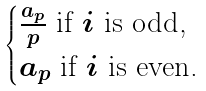<formula> <loc_0><loc_0><loc_500><loc_500>\begin{cases} \frac { a _ { p } } { p } \text { if $i$ is odd,} \\ a _ { p } \text { if $i$ is even.} \end{cases}</formula> 